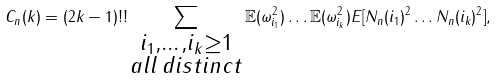Convert formula to latex. <formula><loc_0><loc_0><loc_500><loc_500>C _ { n } ( k ) = ( 2 k - 1 ) ! ! \sum _ { \substack { i _ { 1 } , \dots , i _ { k } \geq 1 \\ a l l \, d i s t i n c t } } \mathbb { E } ( \omega _ { i _ { 1 } } ^ { 2 } ) \dots \mathbb { E } ( \omega _ { i _ { k } } ^ { 2 } ) E [ N _ { n } ( i _ { 1 } ) ^ { 2 } \dots N _ { n } ( i _ { k } ) ^ { 2 } ] ,</formula> 